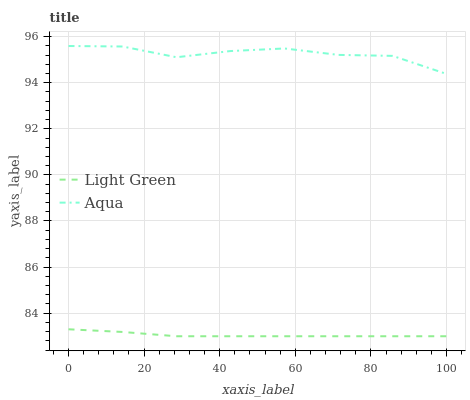Does Light Green have the minimum area under the curve?
Answer yes or no. Yes. Does Aqua have the maximum area under the curve?
Answer yes or no. Yes. Does Light Green have the maximum area under the curve?
Answer yes or no. No. Is Light Green the smoothest?
Answer yes or no. Yes. Is Aqua the roughest?
Answer yes or no. Yes. Is Light Green the roughest?
Answer yes or no. No. Does Light Green have the lowest value?
Answer yes or no. Yes. Does Aqua have the highest value?
Answer yes or no. Yes. Does Light Green have the highest value?
Answer yes or no. No. Is Light Green less than Aqua?
Answer yes or no. Yes. Is Aqua greater than Light Green?
Answer yes or no. Yes. Does Light Green intersect Aqua?
Answer yes or no. No. 